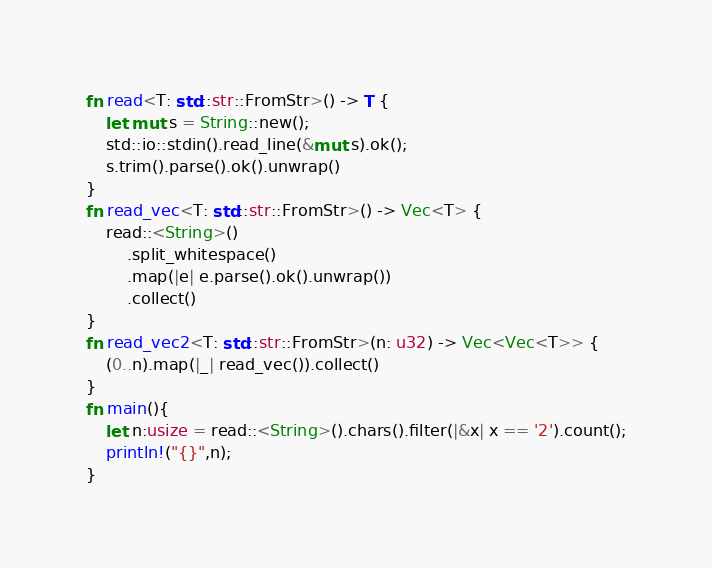Convert code to text. <code><loc_0><loc_0><loc_500><loc_500><_Rust_>fn read<T: std::str::FromStr>() -> T {
    let mut s = String::new();
    std::io::stdin().read_line(&mut s).ok();
    s.trim().parse().ok().unwrap()
}
fn read_vec<T: std::str::FromStr>() -> Vec<T> {
    read::<String>()
        .split_whitespace()
        .map(|e| e.parse().ok().unwrap())
        .collect()
}
fn read_vec2<T: std::str::FromStr>(n: u32) -> Vec<Vec<T>> {
    (0..n).map(|_| read_vec()).collect()
}
fn main(){
    let n:usize = read::<String>().chars().filter(|&x| x == '2').count();
    println!("{}",n);
}</code> 